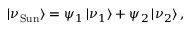Convert formula to latex. <formula><loc_0><loc_0><loc_500><loc_500>| \nu _ { S u n } \rangle = \psi _ { 1 } \, | \nu _ { 1 } \rangle + \psi _ { 2 } \, | \nu _ { 2 } \rangle \, ,</formula> 